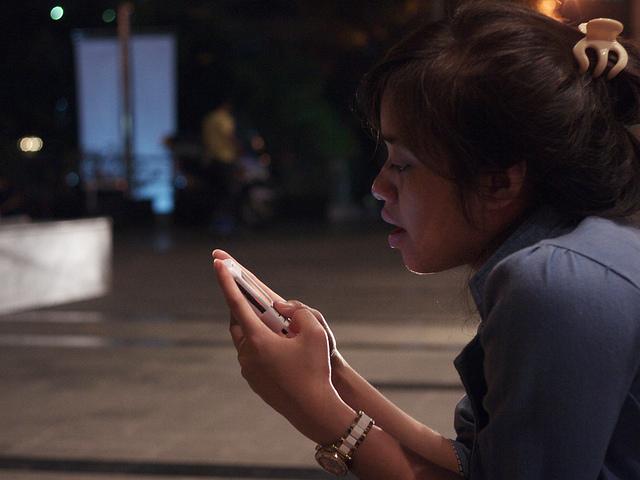Is she wearing a tie?
Keep it brief. No. Is this a play?
Answer briefly. No. What is the girl doing?
Concise answer only. Texting. Is this an event?
Short answer required. No. What game is this person playing?
Keep it brief. Not possible. What is the person sitting on?
Write a very short answer. Bench. What does this woman have on her arm?
Keep it brief. Watch. How many girl are on the bench?
Answer briefly. 1. What is outside the window?
Write a very short answer. People. What is on the woman's head?
Short answer required. Clip. What does the woman have in her hand?
Be succinct. Phone. Is this a man?
Keep it brief. No. What sport is the girl playing?
Keep it brief. None. What kind of shirt is the girl wearing?
Give a very brief answer. Blouse. Is this woman a model?
Answer briefly. No. Is this a warm and sunny climate?
Keep it brief. No. What color is this women's top?
Be succinct. Blue. What is the woman doing?
Be succinct. Texting. What is on her wrist?
Answer briefly. Watch. Is that a backdrop?
Keep it brief. No. What is in the background?
Be succinct. People. What is the man doing?
Short answer required. Texting. Is this woman using a blackberry?
Short answer required. No. What is she wearing in her hair?
Be succinct. Clip. Does the lady have a green ribbon on her hat?
Quick response, please. No. Is the woman using a mobile phone or a calculator?
Be succinct. Phone. Is it bright out?
Answer briefly. No. 